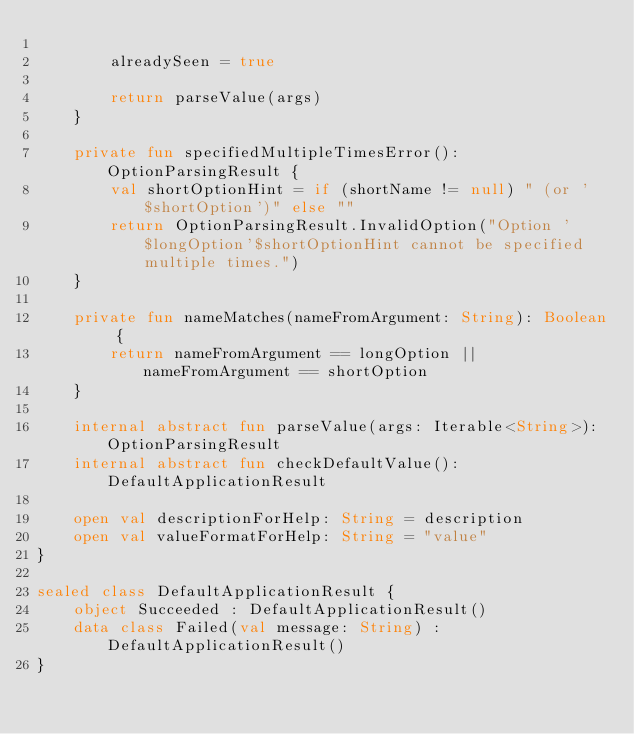Convert code to text. <code><loc_0><loc_0><loc_500><loc_500><_Kotlin_>
        alreadySeen = true

        return parseValue(args)
    }

    private fun specifiedMultipleTimesError(): OptionParsingResult {
        val shortOptionHint = if (shortName != null) " (or '$shortOption')" else ""
        return OptionParsingResult.InvalidOption("Option '$longOption'$shortOptionHint cannot be specified multiple times.")
    }

    private fun nameMatches(nameFromArgument: String): Boolean {
        return nameFromArgument == longOption || nameFromArgument == shortOption
    }

    internal abstract fun parseValue(args: Iterable<String>): OptionParsingResult
    internal abstract fun checkDefaultValue(): DefaultApplicationResult

    open val descriptionForHelp: String = description
    open val valueFormatForHelp: String = "value"
}

sealed class DefaultApplicationResult {
    object Succeeded : DefaultApplicationResult()
    data class Failed(val message: String) : DefaultApplicationResult()
}
</code> 